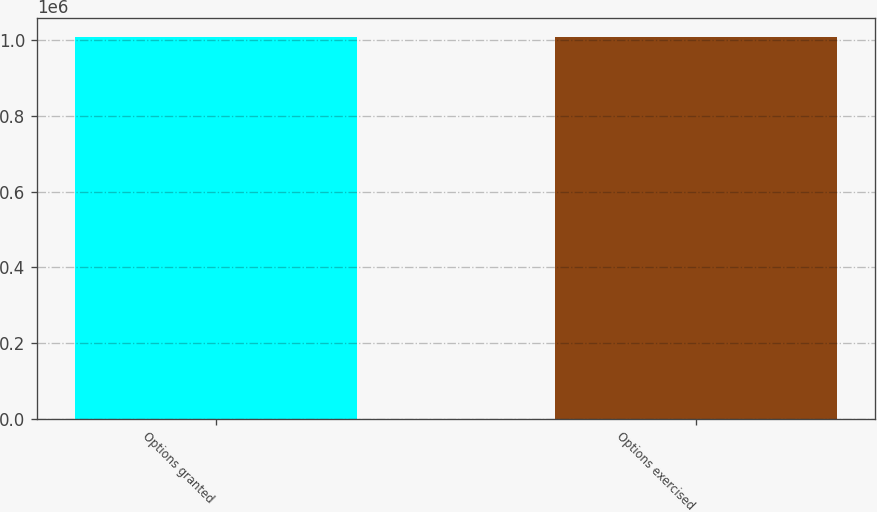Convert chart to OTSL. <chart><loc_0><loc_0><loc_500><loc_500><bar_chart><fcel>Options granted<fcel>Options exercised<nl><fcel>1.00767e+06<fcel>1.00767e+06<nl></chart> 